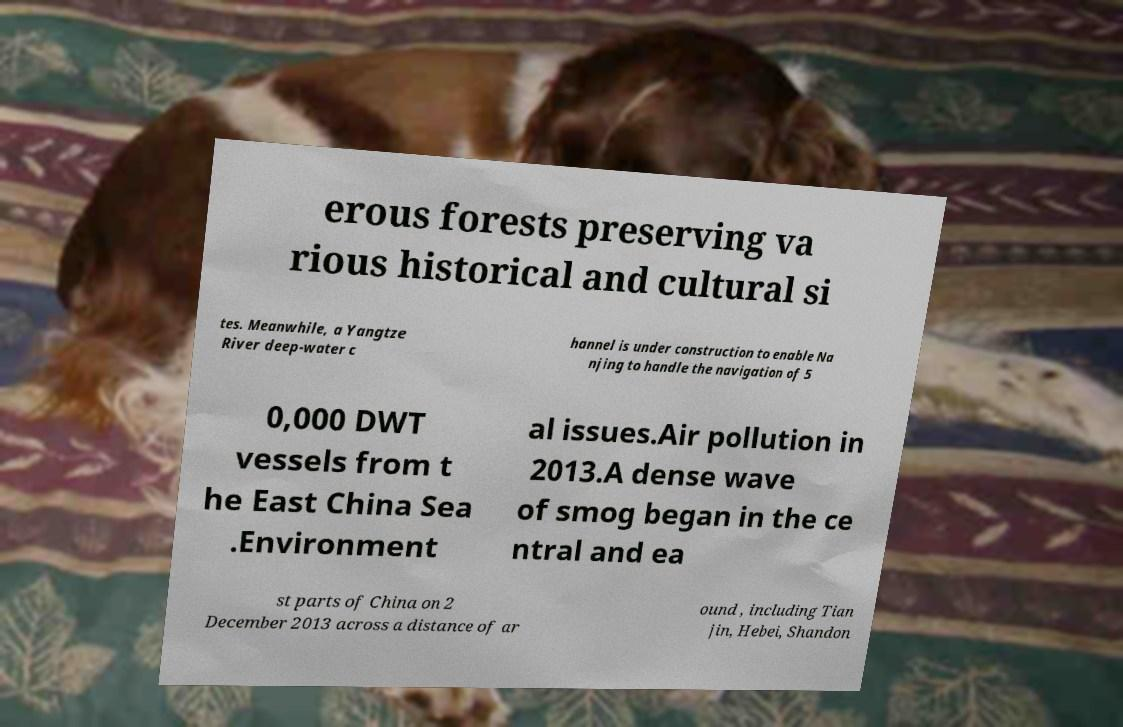What messages or text are displayed in this image? I need them in a readable, typed format. erous forests preserving va rious historical and cultural si tes. Meanwhile, a Yangtze River deep-water c hannel is under construction to enable Na njing to handle the navigation of 5 0,000 DWT vessels from t he East China Sea .Environment al issues.Air pollution in 2013.A dense wave of smog began in the ce ntral and ea st parts of China on 2 December 2013 across a distance of ar ound , including Tian jin, Hebei, Shandon 